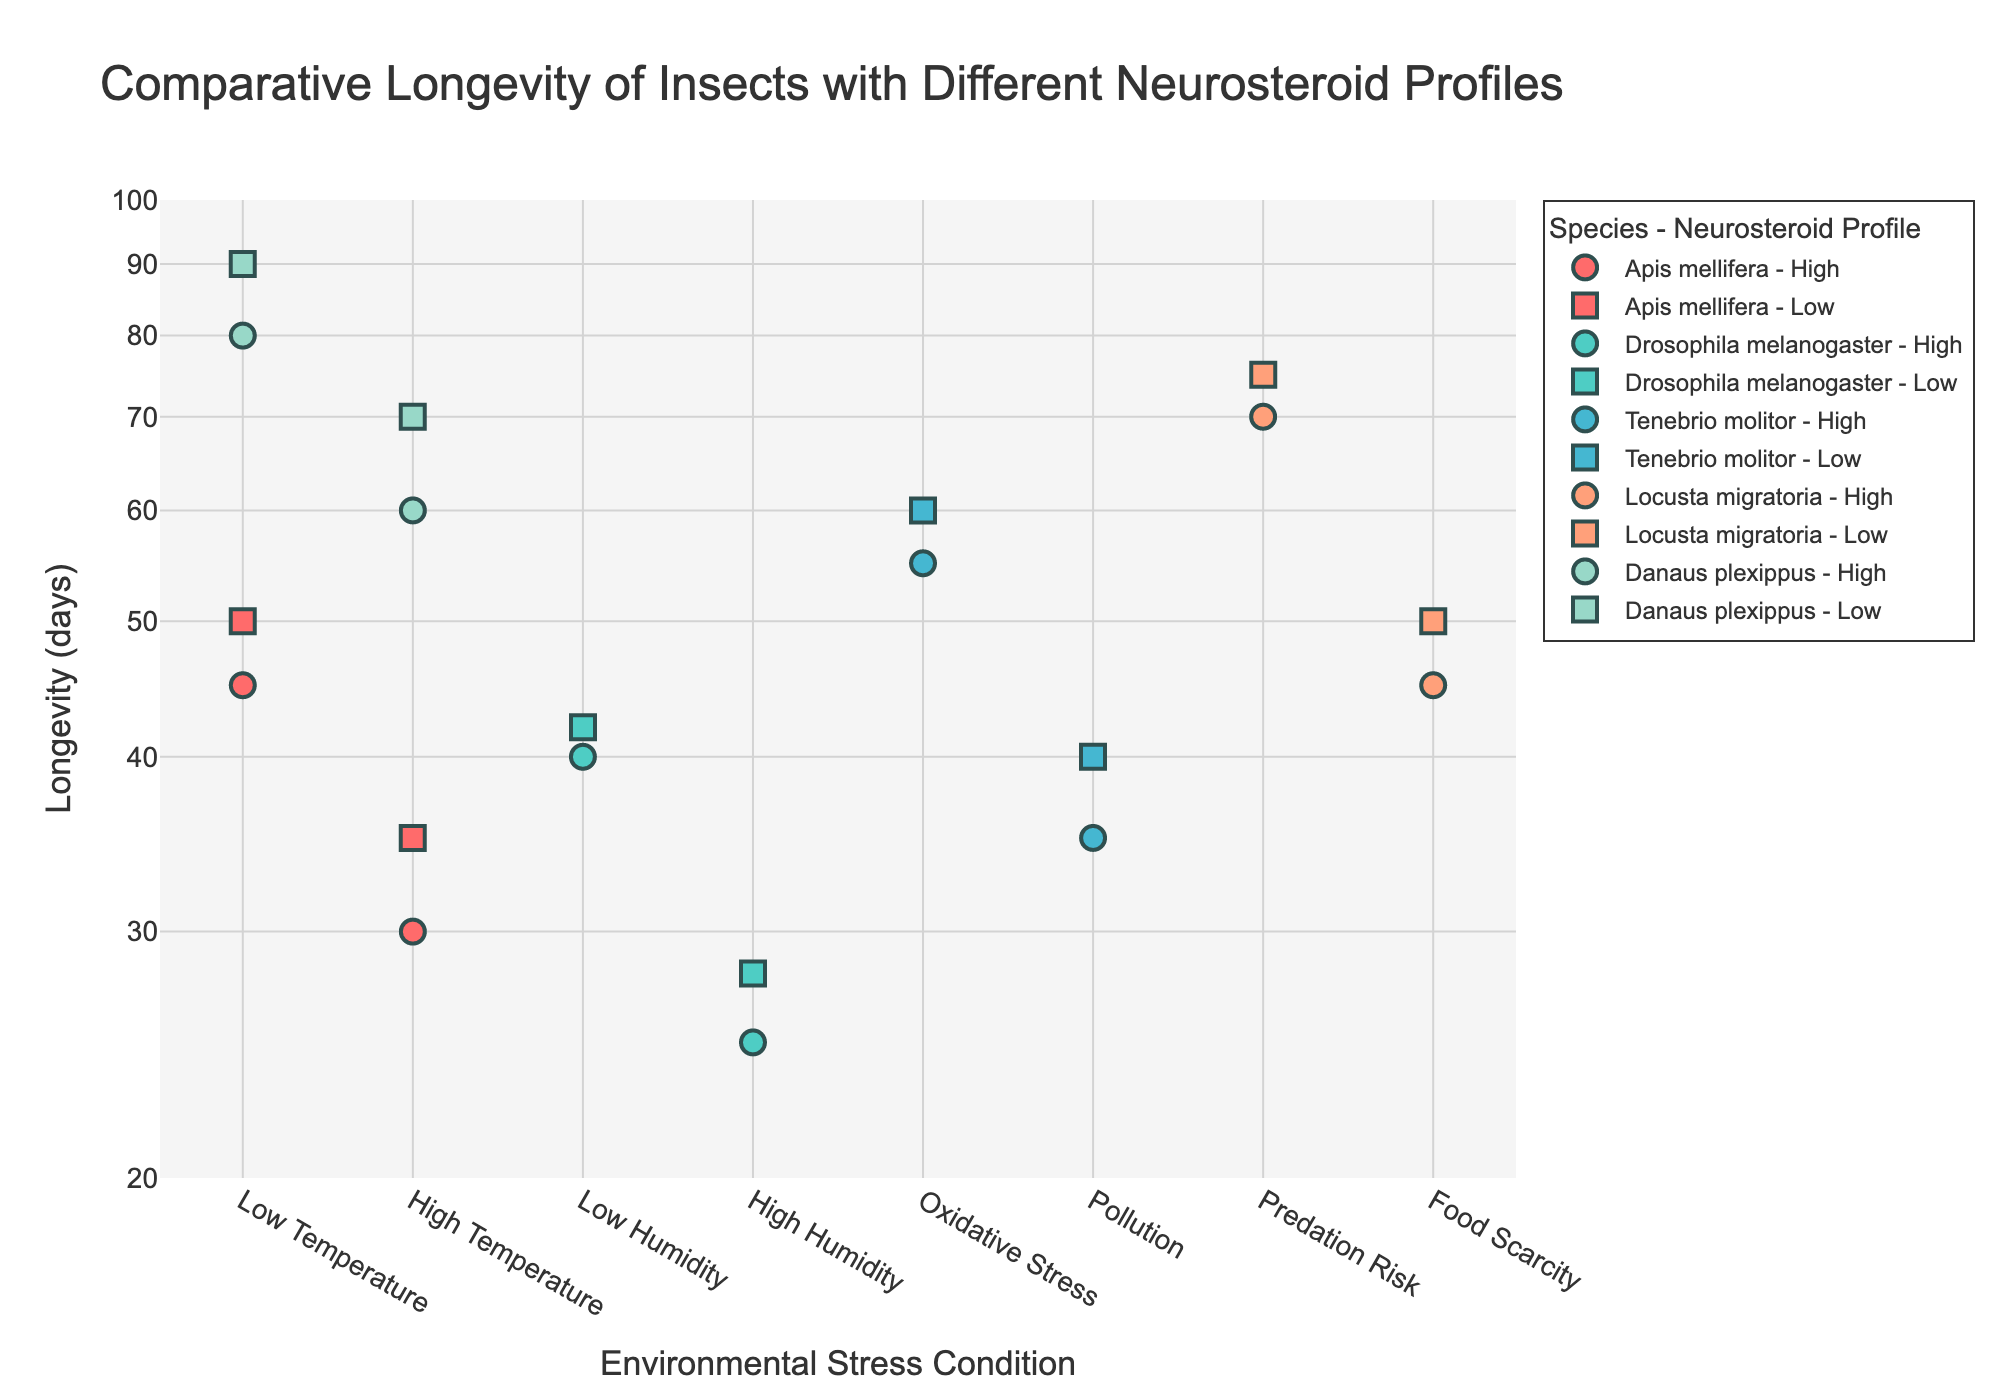What's the title of the scatter plot? The title of the scatter plot is usually displayed at the top of the figure.
Answer: Comparative Longevity of Insects with Different Neurosteroid Profiles Which insect species has the longest recorded longevity in the plot? By examining the y-axis, which represents longevity in days on a log scale, we observe that Danaus plexippus exhibits the longest longevity values.
Answer: Danaus plexippus How many different environmental stress conditions are depicted in the scatter plot? Look at the x-axis labels to count the unique environmental stress conditions listed.
Answer: Five What is the difference in longevity of Apis mellifera under low temperature with high versus low neurosteroid profile? Find the 'Low Temperature' points for Apis mellifera on the plot, look for both 'High' and 'Low' neurosteroid profiles, and calculate the difference between their longevity values.
Answer: 5 days How does the longevity of high neurosteroid profile Drosophila melanogaster under low humidity compare to high humidity? Identify the points for Drosophila melanogaster under 'Low Humidity' and 'High Humidity' with a high neurosteroid profile, then compare their longevity values.
Answer: Low Humidity has higher longevity Which neurosteroid profile tends to have higher longevity under oxidative stress for Tenebrio molitor? Look at the points for Tenebrio molitor under 'Oxidative Stress' and compare the longevity of high versus low neurosteroid profiles.
Answer: Low What is the general trend in longevity for species under high temperature environmental stress condition? Examine all the data points under 'High Temperature' and summarize the general trend in longevity values.
Answer: Longevity decreases What species has the highest longevity under 'Food Scarcity' and what is its neurosteroid profile? Examine the 'Food Scarcity' points and identify the species with the highest longevity, also note its associated neurosteroid profile.
Answer: Locusta migratoria, Low Are there any species where the change in neurosteroid profile under the same environmental condition does not significantly affect longevity? Look for species where the longevity points are close together under the same environmental stress condition despite differing neurosteroid profiles.
Answer: Apis mellifera under 'Low Temperature' Is there a species that consistently shows higher longevity regardless of the environmental stress condition? Check if there is a species with overall higher longevity values under multiple environmental stress conditions.
Answer: Danaus plexippus 